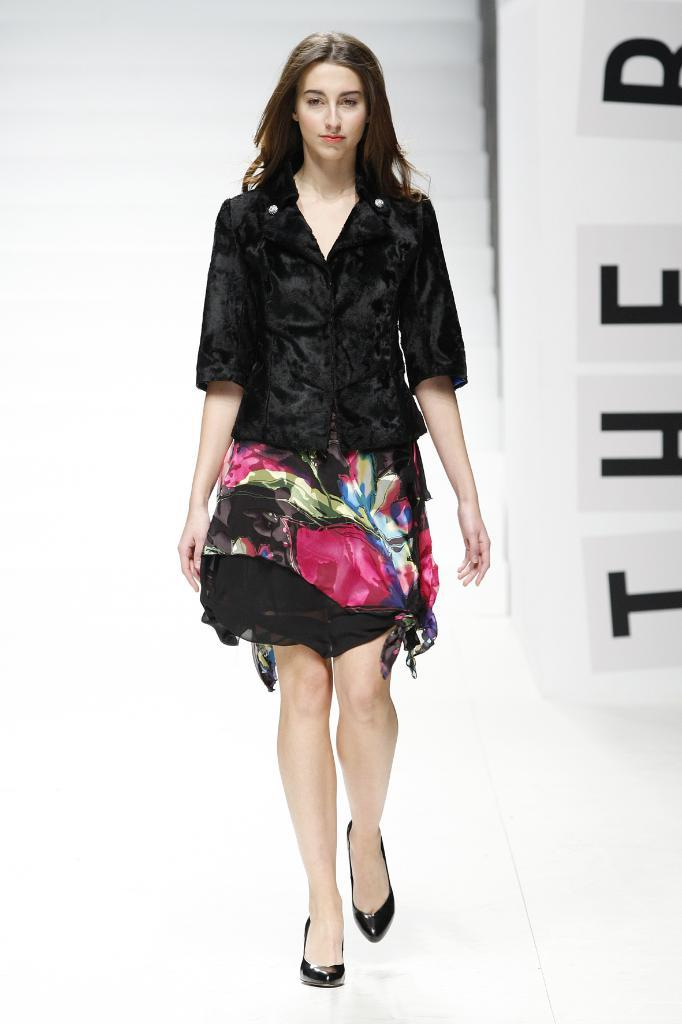Who is the main subject in the image? There is a woman in the image. What is the woman doing in the image? The woman is walking on a platform. Can you describe the background of the image? There are texts written on a platform in the background of the image, but the clarity is uncertain. What type of salt can be seen on the coast in the image? There is no coast or salt present in the image. The woman is walking on a platform, and the background is uncertain. 